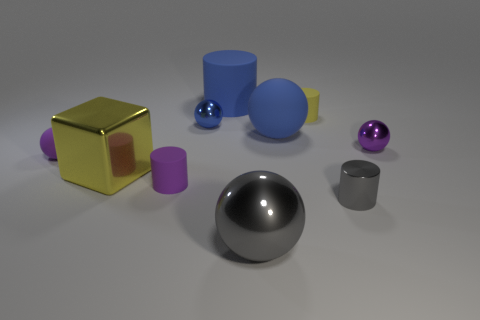Subtract all gray balls. How many balls are left? 4 Subtract all gray spheres. How many spheres are left? 4 Subtract all cyan spheres. Subtract all cyan cylinders. How many spheres are left? 5 Subtract all cylinders. How many objects are left? 6 Add 4 yellow objects. How many yellow objects exist? 6 Subtract 0 yellow balls. How many objects are left? 10 Subtract all large gray things. Subtract all gray metal cylinders. How many objects are left? 8 Add 1 big blue rubber cylinders. How many big blue rubber cylinders are left? 2 